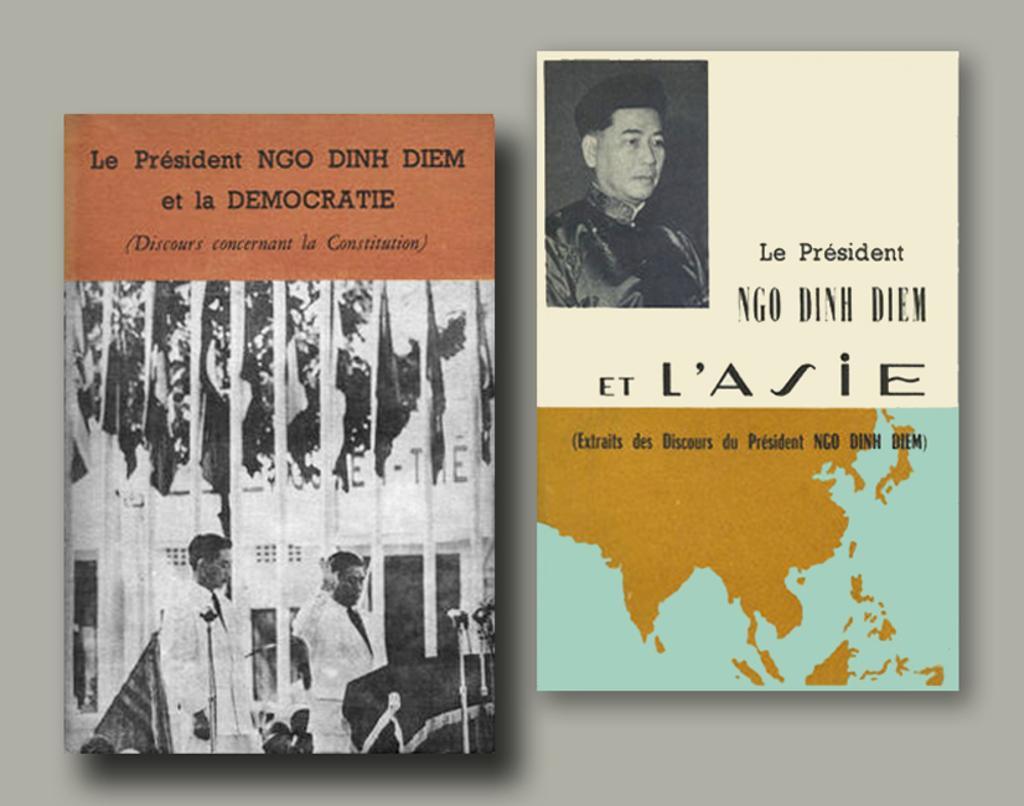How would you summarize this image in a sentence or two? In this image we can see books placed on the surface. 